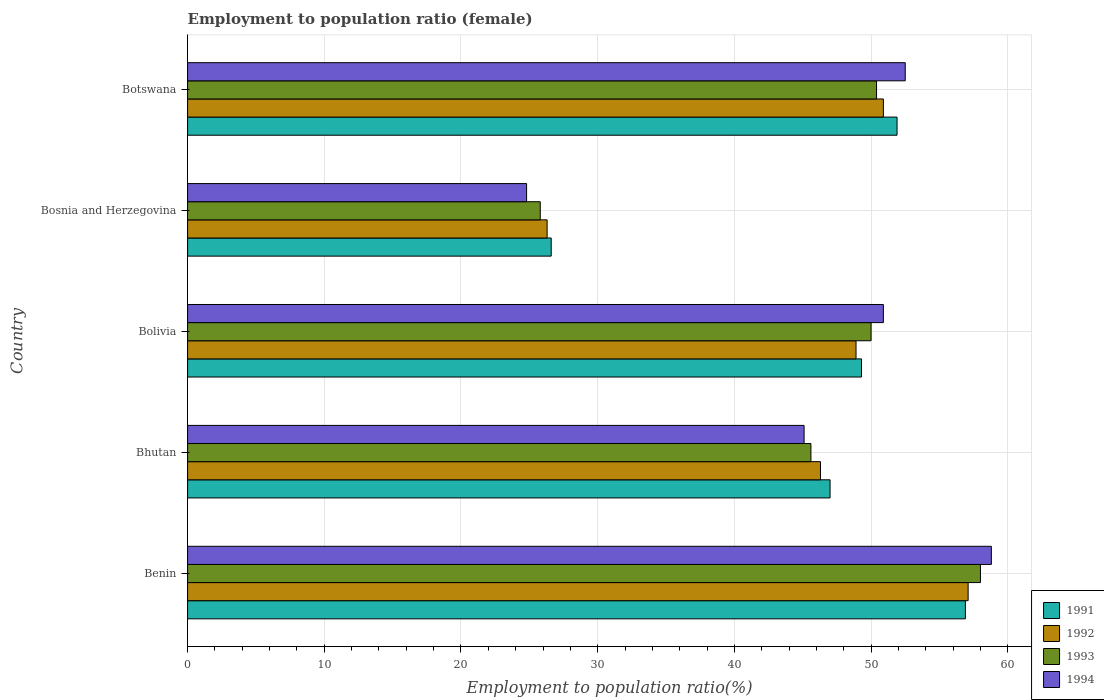How many different coloured bars are there?
Ensure brevity in your answer.  4. What is the label of the 3rd group of bars from the top?
Give a very brief answer. Bolivia. What is the employment to population ratio in 1991 in Bosnia and Herzegovina?
Keep it short and to the point. 26.6. Across all countries, what is the maximum employment to population ratio in 1992?
Your answer should be compact. 57.1. Across all countries, what is the minimum employment to population ratio in 1992?
Give a very brief answer. 26.3. In which country was the employment to population ratio in 1994 maximum?
Provide a short and direct response. Benin. In which country was the employment to population ratio in 1992 minimum?
Ensure brevity in your answer.  Bosnia and Herzegovina. What is the total employment to population ratio in 1992 in the graph?
Your answer should be compact. 229.5. What is the difference between the employment to population ratio in 1994 in Bhutan and that in Botswana?
Offer a very short reply. -7.4. What is the difference between the employment to population ratio in 1991 in Botswana and the employment to population ratio in 1994 in Benin?
Ensure brevity in your answer.  -6.9. What is the average employment to population ratio in 1992 per country?
Provide a succinct answer. 45.9. What is the difference between the employment to population ratio in 1991 and employment to population ratio in 1992 in Bolivia?
Provide a short and direct response. 0.4. In how many countries, is the employment to population ratio in 1992 greater than 32 %?
Provide a short and direct response. 4. What is the ratio of the employment to population ratio in 1994 in Benin to that in Bhutan?
Ensure brevity in your answer.  1.3. What is the difference between the highest and the second highest employment to population ratio in 1991?
Offer a terse response. 5. What is the difference between the highest and the lowest employment to population ratio in 1991?
Offer a very short reply. 30.3. In how many countries, is the employment to population ratio in 1992 greater than the average employment to population ratio in 1992 taken over all countries?
Your answer should be very brief. 4. Is the sum of the employment to population ratio in 1993 in Bolivia and Botswana greater than the maximum employment to population ratio in 1992 across all countries?
Offer a terse response. Yes. Is it the case that in every country, the sum of the employment to population ratio in 1992 and employment to population ratio in 1993 is greater than the sum of employment to population ratio in 1994 and employment to population ratio in 1991?
Your response must be concise. No. Is it the case that in every country, the sum of the employment to population ratio in 1992 and employment to population ratio in 1991 is greater than the employment to population ratio in 1994?
Give a very brief answer. Yes. Are all the bars in the graph horizontal?
Keep it short and to the point. Yes. How many countries are there in the graph?
Provide a short and direct response. 5. Are the values on the major ticks of X-axis written in scientific E-notation?
Offer a very short reply. No. Does the graph contain any zero values?
Offer a terse response. No. Does the graph contain grids?
Your answer should be very brief. Yes. Where does the legend appear in the graph?
Keep it short and to the point. Bottom right. How many legend labels are there?
Your answer should be compact. 4. How are the legend labels stacked?
Your answer should be very brief. Vertical. What is the title of the graph?
Give a very brief answer. Employment to population ratio (female). What is the label or title of the Y-axis?
Offer a very short reply. Country. What is the Employment to population ratio(%) in 1991 in Benin?
Provide a succinct answer. 56.9. What is the Employment to population ratio(%) of 1992 in Benin?
Provide a short and direct response. 57.1. What is the Employment to population ratio(%) of 1994 in Benin?
Your answer should be very brief. 58.8. What is the Employment to population ratio(%) of 1992 in Bhutan?
Your answer should be compact. 46.3. What is the Employment to population ratio(%) in 1993 in Bhutan?
Make the answer very short. 45.6. What is the Employment to population ratio(%) of 1994 in Bhutan?
Offer a very short reply. 45.1. What is the Employment to population ratio(%) in 1991 in Bolivia?
Your answer should be very brief. 49.3. What is the Employment to population ratio(%) in 1992 in Bolivia?
Your answer should be compact. 48.9. What is the Employment to population ratio(%) in 1993 in Bolivia?
Give a very brief answer. 50. What is the Employment to population ratio(%) in 1994 in Bolivia?
Your response must be concise. 50.9. What is the Employment to population ratio(%) in 1991 in Bosnia and Herzegovina?
Provide a short and direct response. 26.6. What is the Employment to population ratio(%) in 1992 in Bosnia and Herzegovina?
Provide a short and direct response. 26.3. What is the Employment to population ratio(%) in 1993 in Bosnia and Herzegovina?
Offer a very short reply. 25.8. What is the Employment to population ratio(%) of 1994 in Bosnia and Herzegovina?
Provide a short and direct response. 24.8. What is the Employment to population ratio(%) in 1991 in Botswana?
Give a very brief answer. 51.9. What is the Employment to population ratio(%) in 1992 in Botswana?
Keep it short and to the point. 50.9. What is the Employment to population ratio(%) of 1993 in Botswana?
Your answer should be very brief. 50.4. What is the Employment to population ratio(%) in 1994 in Botswana?
Offer a very short reply. 52.5. Across all countries, what is the maximum Employment to population ratio(%) in 1991?
Provide a short and direct response. 56.9. Across all countries, what is the maximum Employment to population ratio(%) of 1992?
Your response must be concise. 57.1. Across all countries, what is the maximum Employment to population ratio(%) in 1993?
Your response must be concise. 58. Across all countries, what is the maximum Employment to population ratio(%) in 1994?
Your answer should be compact. 58.8. Across all countries, what is the minimum Employment to population ratio(%) of 1991?
Provide a succinct answer. 26.6. Across all countries, what is the minimum Employment to population ratio(%) in 1992?
Keep it short and to the point. 26.3. Across all countries, what is the minimum Employment to population ratio(%) of 1993?
Provide a short and direct response. 25.8. Across all countries, what is the minimum Employment to population ratio(%) in 1994?
Your answer should be very brief. 24.8. What is the total Employment to population ratio(%) of 1991 in the graph?
Provide a short and direct response. 231.7. What is the total Employment to population ratio(%) in 1992 in the graph?
Your answer should be very brief. 229.5. What is the total Employment to population ratio(%) of 1993 in the graph?
Give a very brief answer. 229.8. What is the total Employment to population ratio(%) of 1994 in the graph?
Your answer should be very brief. 232.1. What is the difference between the Employment to population ratio(%) in 1991 in Benin and that in Bhutan?
Your response must be concise. 9.9. What is the difference between the Employment to population ratio(%) in 1991 in Benin and that in Bolivia?
Ensure brevity in your answer.  7.6. What is the difference between the Employment to population ratio(%) of 1993 in Benin and that in Bolivia?
Your answer should be very brief. 8. What is the difference between the Employment to population ratio(%) in 1991 in Benin and that in Bosnia and Herzegovina?
Offer a very short reply. 30.3. What is the difference between the Employment to population ratio(%) of 1992 in Benin and that in Bosnia and Herzegovina?
Make the answer very short. 30.8. What is the difference between the Employment to population ratio(%) of 1993 in Benin and that in Bosnia and Herzegovina?
Ensure brevity in your answer.  32.2. What is the difference between the Employment to population ratio(%) in 1994 in Benin and that in Bosnia and Herzegovina?
Make the answer very short. 34. What is the difference between the Employment to population ratio(%) in 1991 in Benin and that in Botswana?
Offer a very short reply. 5. What is the difference between the Employment to population ratio(%) in 1992 in Benin and that in Botswana?
Provide a succinct answer. 6.2. What is the difference between the Employment to population ratio(%) of 1993 in Benin and that in Botswana?
Provide a short and direct response. 7.6. What is the difference between the Employment to population ratio(%) of 1991 in Bhutan and that in Bolivia?
Offer a terse response. -2.3. What is the difference between the Employment to population ratio(%) of 1992 in Bhutan and that in Bolivia?
Provide a succinct answer. -2.6. What is the difference between the Employment to population ratio(%) in 1994 in Bhutan and that in Bolivia?
Offer a terse response. -5.8. What is the difference between the Employment to population ratio(%) of 1991 in Bhutan and that in Bosnia and Herzegovina?
Offer a terse response. 20.4. What is the difference between the Employment to population ratio(%) of 1993 in Bhutan and that in Bosnia and Herzegovina?
Offer a terse response. 19.8. What is the difference between the Employment to population ratio(%) of 1994 in Bhutan and that in Bosnia and Herzegovina?
Give a very brief answer. 20.3. What is the difference between the Employment to population ratio(%) in 1992 in Bhutan and that in Botswana?
Make the answer very short. -4.6. What is the difference between the Employment to population ratio(%) in 1993 in Bhutan and that in Botswana?
Ensure brevity in your answer.  -4.8. What is the difference between the Employment to population ratio(%) in 1991 in Bolivia and that in Bosnia and Herzegovina?
Give a very brief answer. 22.7. What is the difference between the Employment to population ratio(%) of 1992 in Bolivia and that in Bosnia and Herzegovina?
Provide a short and direct response. 22.6. What is the difference between the Employment to population ratio(%) of 1993 in Bolivia and that in Bosnia and Herzegovina?
Make the answer very short. 24.2. What is the difference between the Employment to population ratio(%) of 1994 in Bolivia and that in Bosnia and Herzegovina?
Offer a very short reply. 26.1. What is the difference between the Employment to population ratio(%) in 1993 in Bolivia and that in Botswana?
Offer a very short reply. -0.4. What is the difference between the Employment to population ratio(%) in 1994 in Bolivia and that in Botswana?
Provide a succinct answer. -1.6. What is the difference between the Employment to population ratio(%) in 1991 in Bosnia and Herzegovina and that in Botswana?
Offer a terse response. -25.3. What is the difference between the Employment to population ratio(%) of 1992 in Bosnia and Herzegovina and that in Botswana?
Your response must be concise. -24.6. What is the difference between the Employment to population ratio(%) of 1993 in Bosnia and Herzegovina and that in Botswana?
Offer a very short reply. -24.6. What is the difference between the Employment to population ratio(%) of 1994 in Bosnia and Herzegovina and that in Botswana?
Offer a terse response. -27.7. What is the difference between the Employment to population ratio(%) of 1991 in Benin and the Employment to population ratio(%) of 1992 in Bhutan?
Keep it short and to the point. 10.6. What is the difference between the Employment to population ratio(%) in 1992 in Benin and the Employment to population ratio(%) in 1994 in Bhutan?
Give a very brief answer. 12. What is the difference between the Employment to population ratio(%) of 1993 in Benin and the Employment to population ratio(%) of 1994 in Bhutan?
Ensure brevity in your answer.  12.9. What is the difference between the Employment to population ratio(%) in 1991 in Benin and the Employment to population ratio(%) in 1994 in Bolivia?
Offer a terse response. 6. What is the difference between the Employment to population ratio(%) of 1992 in Benin and the Employment to population ratio(%) of 1993 in Bolivia?
Ensure brevity in your answer.  7.1. What is the difference between the Employment to population ratio(%) in 1993 in Benin and the Employment to population ratio(%) in 1994 in Bolivia?
Make the answer very short. 7.1. What is the difference between the Employment to population ratio(%) of 1991 in Benin and the Employment to population ratio(%) of 1992 in Bosnia and Herzegovina?
Provide a short and direct response. 30.6. What is the difference between the Employment to population ratio(%) in 1991 in Benin and the Employment to population ratio(%) in 1993 in Bosnia and Herzegovina?
Provide a succinct answer. 31.1. What is the difference between the Employment to population ratio(%) in 1991 in Benin and the Employment to population ratio(%) in 1994 in Bosnia and Herzegovina?
Give a very brief answer. 32.1. What is the difference between the Employment to population ratio(%) in 1992 in Benin and the Employment to population ratio(%) in 1993 in Bosnia and Herzegovina?
Provide a short and direct response. 31.3. What is the difference between the Employment to population ratio(%) in 1992 in Benin and the Employment to population ratio(%) in 1994 in Bosnia and Herzegovina?
Your response must be concise. 32.3. What is the difference between the Employment to population ratio(%) in 1993 in Benin and the Employment to population ratio(%) in 1994 in Bosnia and Herzegovina?
Keep it short and to the point. 33.2. What is the difference between the Employment to population ratio(%) in 1991 in Benin and the Employment to population ratio(%) in 1993 in Botswana?
Make the answer very short. 6.5. What is the difference between the Employment to population ratio(%) of 1992 in Benin and the Employment to population ratio(%) of 1994 in Botswana?
Provide a succinct answer. 4.6. What is the difference between the Employment to population ratio(%) of 1993 in Benin and the Employment to population ratio(%) of 1994 in Botswana?
Your answer should be very brief. 5.5. What is the difference between the Employment to population ratio(%) in 1992 in Bhutan and the Employment to population ratio(%) in 1993 in Bolivia?
Give a very brief answer. -3.7. What is the difference between the Employment to population ratio(%) in 1992 in Bhutan and the Employment to population ratio(%) in 1994 in Bolivia?
Ensure brevity in your answer.  -4.6. What is the difference between the Employment to population ratio(%) of 1991 in Bhutan and the Employment to population ratio(%) of 1992 in Bosnia and Herzegovina?
Give a very brief answer. 20.7. What is the difference between the Employment to population ratio(%) in 1991 in Bhutan and the Employment to population ratio(%) in 1993 in Bosnia and Herzegovina?
Offer a terse response. 21.2. What is the difference between the Employment to population ratio(%) in 1991 in Bhutan and the Employment to population ratio(%) in 1994 in Bosnia and Herzegovina?
Your answer should be very brief. 22.2. What is the difference between the Employment to population ratio(%) in 1993 in Bhutan and the Employment to population ratio(%) in 1994 in Bosnia and Herzegovina?
Your answer should be very brief. 20.8. What is the difference between the Employment to population ratio(%) in 1991 in Bhutan and the Employment to population ratio(%) in 1992 in Botswana?
Offer a terse response. -3.9. What is the difference between the Employment to population ratio(%) in 1991 in Bhutan and the Employment to population ratio(%) in 1993 in Botswana?
Offer a very short reply. -3.4. What is the difference between the Employment to population ratio(%) of 1992 in Bhutan and the Employment to population ratio(%) of 1993 in Botswana?
Offer a very short reply. -4.1. What is the difference between the Employment to population ratio(%) of 1992 in Bhutan and the Employment to population ratio(%) of 1994 in Botswana?
Offer a terse response. -6.2. What is the difference between the Employment to population ratio(%) of 1991 in Bolivia and the Employment to population ratio(%) of 1994 in Bosnia and Herzegovina?
Offer a very short reply. 24.5. What is the difference between the Employment to population ratio(%) in 1992 in Bolivia and the Employment to population ratio(%) in 1993 in Bosnia and Herzegovina?
Your response must be concise. 23.1. What is the difference between the Employment to population ratio(%) in 1992 in Bolivia and the Employment to population ratio(%) in 1994 in Bosnia and Herzegovina?
Offer a terse response. 24.1. What is the difference between the Employment to population ratio(%) in 1993 in Bolivia and the Employment to population ratio(%) in 1994 in Bosnia and Herzegovina?
Your response must be concise. 25.2. What is the difference between the Employment to population ratio(%) in 1992 in Bolivia and the Employment to population ratio(%) in 1993 in Botswana?
Keep it short and to the point. -1.5. What is the difference between the Employment to population ratio(%) of 1993 in Bolivia and the Employment to population ratio(%) of 1994 in Botswana?
Your answer should be compact. -2.5. What is the difference between the Employment to population ratio(%) of 1991 in Bosnia and Herzegovina and the Employment to population ratio(%) of 1992 in Botswana?
Keep it short and to the point. -24.3. What is the difference between the Employment to population ratio(%) of 1991 in Bosnia and Herzegovina and the Employment to population ratio(%) of 1993 in Botswana?
Give a very brief answer. -23.8. What is the difference between the Employment to population ratio(%) in 1991 in Bosnia and Herzegovina and the Employment to population ratio(%) in 1994 in Botswana?
Give a very brief answer. -25.9. What is the difference between the Employment to population ratio(%) in 1992 in Bosnia and Herzegovina and the Employment to population ratio(%) in 1993 in Botswana?
Offer a very short reply. -24.1. What is the difference between the Employment to population ratio(%) of 1992 in Bosnia and Herzegovina and the Employment to population ratio(%) of 1994 in Botswana?
Offer a very short reply. -26.2. What is the difference between the Employment to population ratio(%) in 1993 in Bosnia and Herzegovina and the Employment to population ratio(%) in 1994 in Botswana?
Make the answer very short. -26.7. What is the average Employment to population ratio(%) of 1991 per country?
Provide a succinct answer. 46.34. What is the average Employment to population ratio(%) of 1992 per country?
Provide a succinct answer. 45.9. What is the average Employment to population ratio(%) in 1993 per country?
Make the answer very short. 45.96. What is the average Employment to population ratio(%) in 1994 per country?
Keep it short and to the point. 46.42. What is the difference between the Employment to population ratio(%) in 1991 and Employment to population ratio(%) in 1992 in Benin?
Your response must be concise. -0.2. What is the difference between the Employment to population ratio(%) of 1992 and Employment to population ratio(%) of 1994 in Benin?
Give a very brief answer. -1.7. What is the difference between the Employment to population ratio(%) in 1993 and Employment to population ratio(%) in 1994 in Benin?
Offer a terse response. -0.8. What is the difference between the Employment to population ratio(%) of 1991 and Employment to population ratio(%) of 1994 in Bhutan?
Provide a succinct answer. 1.9. What is the difference between the Employment to population ratio(%) of 1992 and Employment to population ratio(%) of 1994 in Bhutan?
Your answer should be very brief. 1.2. What is the difference between the Employment to population ratio(%) in 1991 and Employment to population ratio(%) in 1992 in Bolivia?
Offer a terse response. 0.4. What is the difference between the Employment to population ratio(%) in 1991 and Employment to population ratio(%) in 1993 in Bolivia?
Your answer should be compact. -0.7. What is the difference between the Employment to population ratio(%) of 1993 and Employment to population ratio(%) of 1994 in Bolivia?
Offer a very short reply. -0.9. What is the difference between the Employment to population ratio(%) of 1991 and Employment to population ratio(%) of 1993 in Bosnia and Herzegovina?
Provide a succinct answer. 0.8. What is the difference between the Employment to population ratio(%) of 1991 and Employment to population ratio(%) of 1992 in Botswana?
Your response must be concise. 1. What is the difference between the Employment to population ratio(%) of 1991 and Employment to population ratio(%) of 1993 in Botswana?
Offer a terse response. 1.5. What is the difference between the Employment to population ratio(%) of 1991 and Employment to population ratio(%) of 1994 in Botswana?
Your answer should be very brief. -0.6. What is the difference between the Employment to population ratio(%) in 1992 and Employment to population ratio(%) in 1993 in Botswana?
Offer a very short reply. 0.5. What is the difference between the Employment to population ratio(%) of 1992 and Employment to population ratio(%) of 1994 in Botswana?
Offer a terse response. -1.6. What is the ratio of the Employment to population ratio(%) in 1991 in Benin to that in Bhutan?
Your answer should be compact. 1.21. What is the ratio of the Employment to population ratio(%) of 1992 in Benin to that in Bhutan?
Provide a short and direct response. 1.23. What is the ratio of the Employment to population ratio(%) in 1993 in Benin to that in Bhutan?
Your answer should be very brief. 1.27. What is the ratio of the Employment to population ratio(%) in 1994 in Benin to that in Bhutan?
Provide a succinct answer. 1.3. What is the ratio of the Employment to population ratio(%) in 1991 in Benin to that in Bolivia?
Provide a short and direct response. 1.15. What is the ratio of the Employment to population ratio(%) in 1992 in Benin to that in Bolivia?
Give a very brief answer. 1.17. What is the ratio of the Employment to population ratio(%) in 1993 in Benin to that in Bolivia?
Your answer should be compact. 1.16. What is the ratio of the Employment to population ratio(%) of 1994 in Benin to that in Bolivia?
Make the answer very short. 1.16. What is the ratio of the Employment to population ratio(%) in 1991 in Benin to that in Bosnia and Herzegovina?
Offer a terse response. 2.14. What is the ratio of the Employment to population ratio(%) in 1992 in Benin to that in Bosnia and Herzegovina?
Ensure brevity in your answer.  2.17. What is the ratio of the Employment to population ratio(%) of 1993 in Benin to that in Bosnia and Herzegovina?
Your answer should be very brief. 2.25. What is the ratio of the Employment to population ratio(%) in 1994 in Benin to that in Bosnia and Herzegovina?
Your response must be concise. 2.37. What is the ratio of the Employment to population ratio(%) of 1991 in Benin to that in Botswana?
Keep it short and to the point. 1.1. What is the ratio of the Employment to population ratio(%) in 1992 in Benin to that in Botswana?
Keep it short and to the point. 1.12. What is the ratio of the Employment to population ratio(%) of 1993 in Benin to that in Botswana?
Provide a short and direct response. 1.15. What is the ratio of the Employment to population ratio(%) of 1994 in Benin to that in Botswana?
Keep it short and to the point. 1.12. What is the ratio of the Employment to population ratio(%) of 1991 in Bhutan to that in Bolivia?
Provide a short and direct response. 0.95. What is the ratio of the Employment to population ratio(%) of 1992 in Bhutan to that in Bolivia?
Make the answer very short. 0.95. What is the ratio of the Employment to population ratio(%) in 1993 in Bhutan to that in Bolivia?
Provide a short and direct response. 0.91. What is the ratio of the Employment to population ratio(%) in 1994 in Bhutan to that in Bolivia?
Your answer should be compact. 0.89. What is the ratio of the Employment to population ratio(%) of 1991 in Bhutan to that in Bosnia and Herzegovina?
Your answer should be compact. 1.77. What is the ratio of the Employment to population ratio(%) of 1992 in Bhutan to that in Bosnia and Herzegovina?
Your answer should be very brief. 1.76. What is the ratio of the Employment to population ratio(%) of 1993 in Bhutan to that in Bosnia and Herzegovina?
Ensure brevity in your answer.  1.77. What is the ratio of the Employment to population ratio(%) in 1994 in Bhutan to that in Bosnia and Herzegovina?
Your response must be concise. 1.82. What is the ratio of the Employment to population ratio(%) in 1991 in Bhutan to that in Botswana?
Provide a short and direct response. 0.91. What is the ratio of the Employment to population ratio(%) of 1992 in Bhutan to that in Botswana?
Offer a very short reply. 0.91. What is the ratio of the Employment to population ratio(%) in 1993 in Bhutan to that in Botswana?
Your answer should be compact. 0.9. What is the ratio of the Employment to population ratio(%) of 1994 in Bhutan to that in Botswana?
Ensure brevity in your answer.  0.86. What is the ratio of the Employment to population ratio(%) of 1991 in Bolivia to that in Bosnia and Herzegovina?
Make the answer very short. 1.85. What is the ratio of the Employment to population ratio(%) in 1992 in Bolivia to that in Bosnia and Herzegovina?
Offer a very short reply. 1.86. What is the ratio of the Employment to population ratio(%) in 1993 in Bolivia to that in Bosnia and Herzegovina?
Your response must be concise. 1.94. What is the ratio of the Employment to population ratio(%) of 1994 in Bolivia to that in Bosnia and Herzegovina?
Give a very brief answer. 2.05. What is the ratio of the Employment to population ratio(%) of 1991 in Bolivia to that in Botswana?
Provide a succinct answer. 0.95. What is the ratio of the Employment to population ratio(%) of 1992 in Bolivia to that in Botswana?
Your response must be concise. 0.96. What is the ratio of the Employment to population ratio(%) in 1994 in Bolivia to that in Botswana?
Your response must be concise. 0.97. What is the ratio of the Employment to population ratio(%) of 1991 in Bosnia and Herzegovina to that in Botswana?
Keep it short and to the point. 0.51. What is the ratio of the Employment to population ratio(%) in 1992 in Bosnia and Herzegovina to that in Botswana?
Make the answer very short. 0.52. What is the ratio of the Employment to population ratio(%) in 1993 in Bosnia and Herzegovina to that in Botswana?
Your answer should be very brief. 0.51. What is the ratio of the Employment to population ratio(%) of 1994 in Bosnia and Herzegovina to that in Botswana?
Provide a succinct answer. 0.47. What is the difference between the highest and the second highest Employment to population ratio(%) in 1994?
Ensure brevity in your answer.  6.3. What is the difference between the highest and the lowest Employment to population ratio(%) of 1991?
Offer a very short reply. 30.3. What is the difference between the highest and the lowest Employment to population ratio(%) of 1992?
Keep it short and to the point. 30.8. What is the difference between the highest and the lowest Employment to population ratio(%) in 1993?
Provide a short and direct response. 32.2. What is the difference between the highest and the lowest Employment to population ratio(%) in 1994?
Give a very brief answer. 34. 